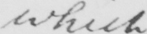Can you tell me what this handwritten text says? which " 